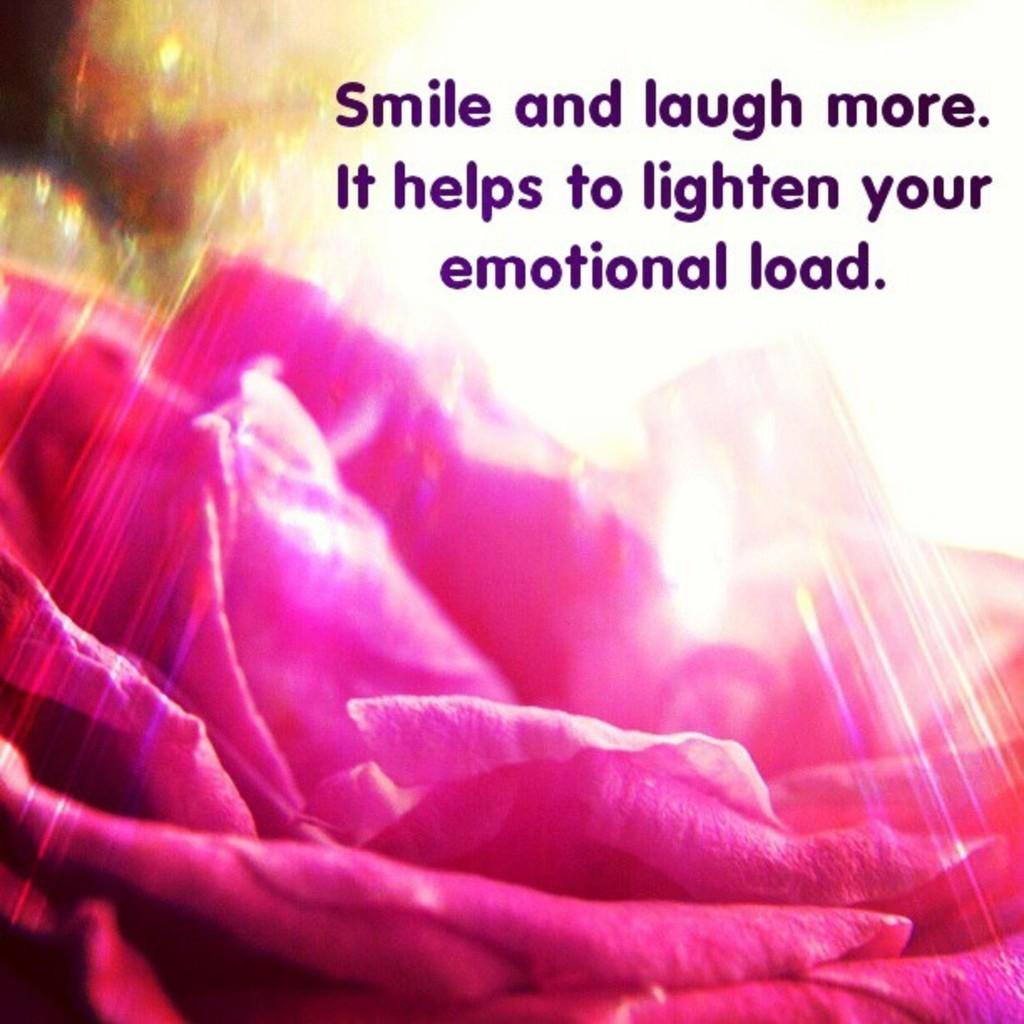What is depicted in the image? There is a picture of a flower in the image. What else can be seen on the image besides the flower? There is text present on the image. What type of property is visible in the image? There is no property visible in the image; it only features a picture of a flower and text. How many bricks can be seen in the image? There are no bricks present in the image. 